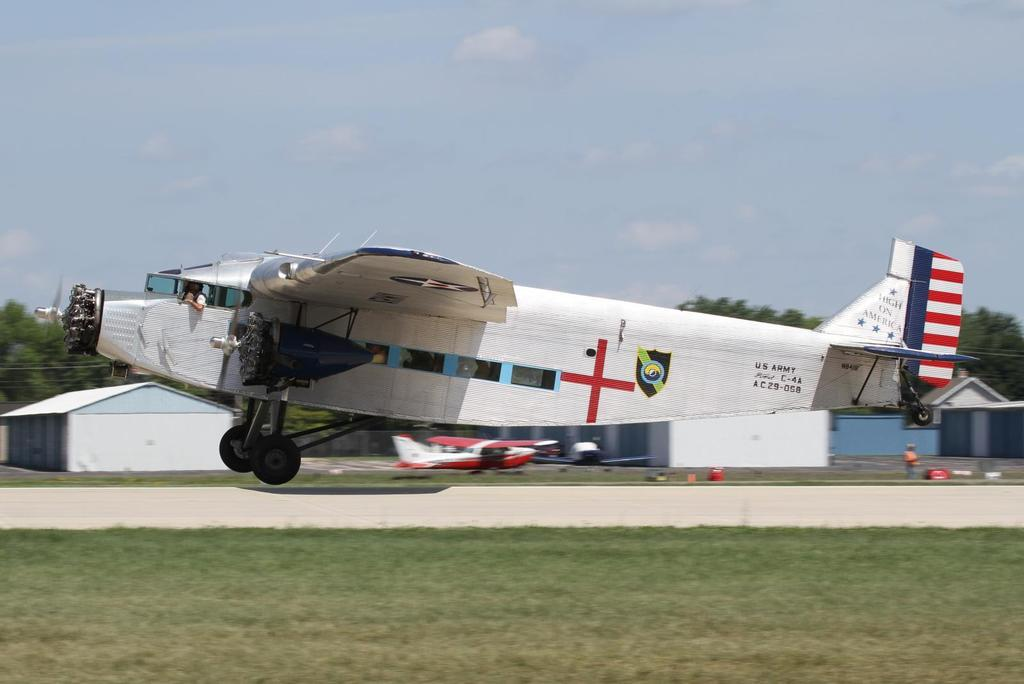Provide a one-sentence caption for the provided image. a US Army High on America C-4A A C 29-058 with a red cross on it. 